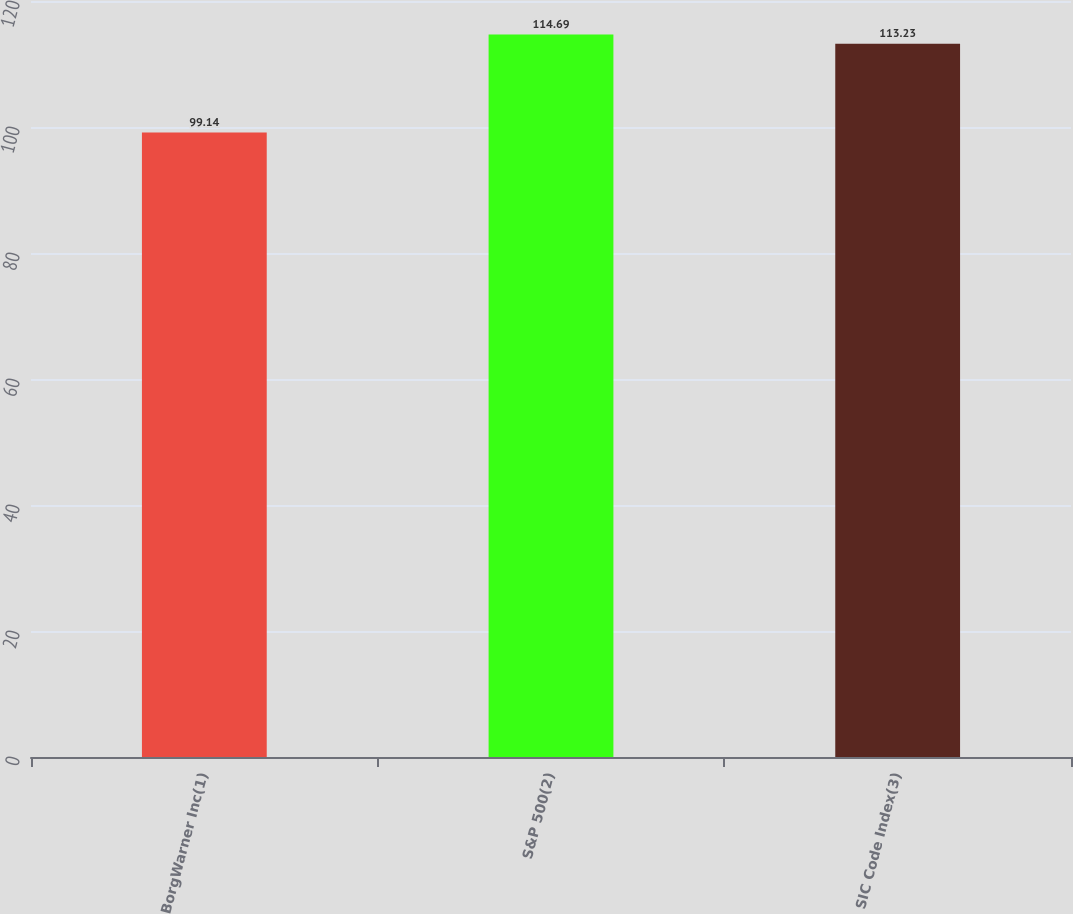Convert chart. <chart><loc_0><loc_0><loc_500><loc_500><bar_chart><fcel>BorgWarner Inc(1)<fcel>S&P 500(2)<fcel>SIC Code Index(3)<nl><fcel>99.14<fcel>114.69<fcel>113.23<nl></chart> 